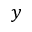<formula> <loc_0><loc_0><loc_500><loc_500>y</formula> 